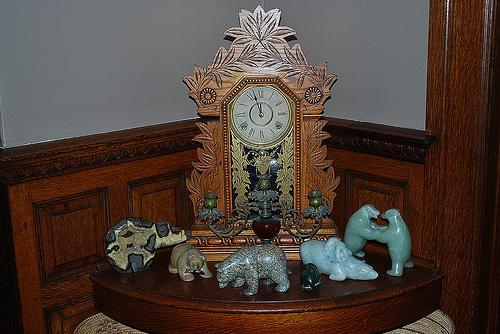Describe the clock in the image. The clock is large, ornately carved, with gold hands, a face featuring Roman numerals, and shows a time of 11:56. Provide a concise description of the table and its contents. A wooden table holds a decorative clock, bear figurines in various poses, and a candlestick holder without candles. Summarize the theme of the image. The image depicts a cozy scene featuring a wooden table adorned with a clock and a collection of bear figurines. Describe the setting of the image in one sentence. The image features a wooden table with a clock and multiple bear-themed ornaments against a white wall and a wooden door frame. Narrate the scene displayed in the image. On a wooden table, there's a beautiful clock alongside an array of bear figurines in different poses, such as fighting, dancing, and holding a fish. Mention the most distinctive feature of the image. The clock and diverse bear figurines create an interesting and unified theme on the wooden table. Mention the central object in the image and its surroundings. The large decorative clock sits prominently on a wooden table, surrounded by bear figurines and a candlestick holder without candles. Describe the types of bear figurines in the image. The bear figurines include a brown bear, a bear with a fish, a bear with a cub, two fighting bears, and two dancing bears. Provide a brief description of the key items in the image. A wooden table with a large decorative clock and various bear figurines, including one fighting pair and a bear with a fish. Describe the overall atmosphere created by the items in the image. A warm and inviting atmosphere is created by the combination of the wooden table, decorative clock, and charming bear figurines. 